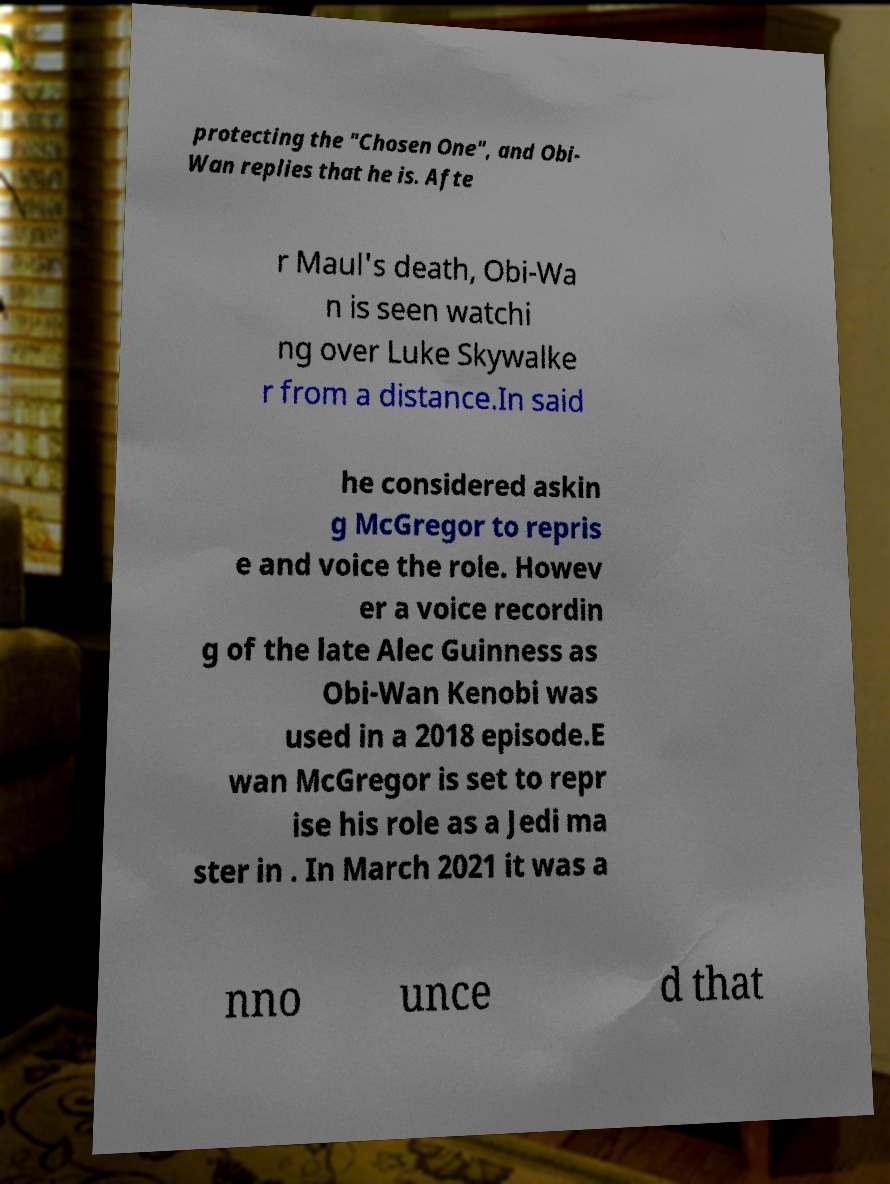Could you assist in decoding the text presented in this image and type it out clearly? protecting the "Chosen One", and Obi- Wan replies that he is. Afte r Maul's death, Obi-Wa n is seen watchi ng over Luke Skywalke r from a distance.In said he considered askin g McGregor to repris e and voice the role. Howev er a voice recordin g of the late Alec Guinness as Obi-Wan Kenobi was used in a 2018 episode.E wan McGregor is set to repr ise his role as a Jedi ma ster in . In March 2021 it was a nno unce d that 